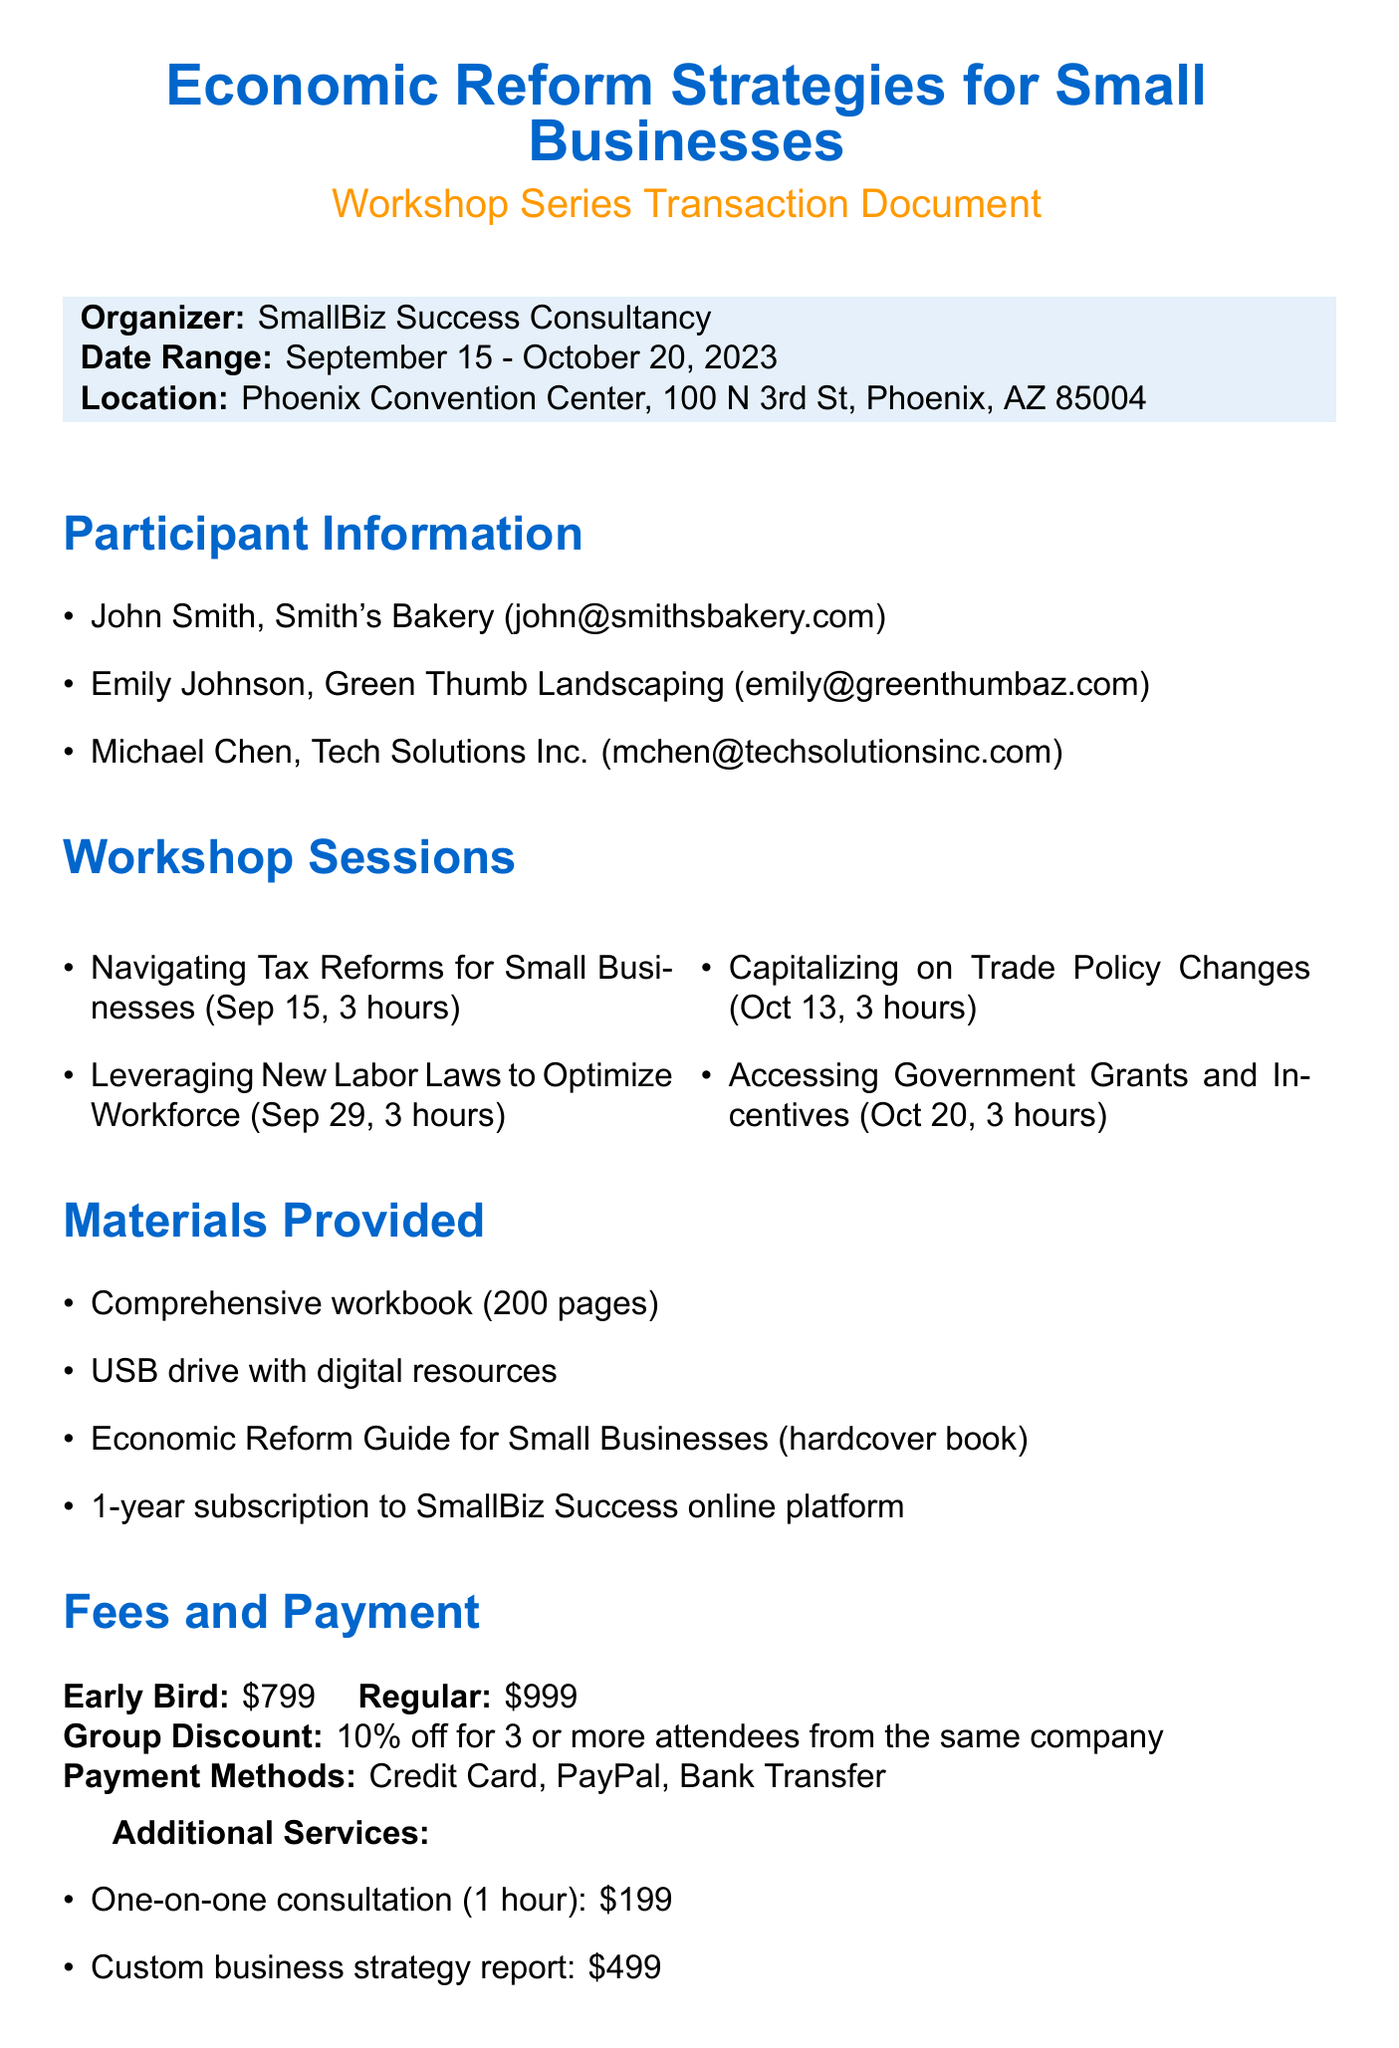What is the workshop series title? The workshop series title is explicitly stated at the top of the document.
Answer: Economic Reform Strategies for Small Businesses Who is the organizer of the workshops? The document identifies the organization responsible for the workshops.
Answer: SmallBiz Success Consultancy What is the duration of each workshop session? The duration is mentioned for each of the workshop sessions listed in the document.
Answer: 3 hours What is the early bird fee for the workshops? The early bird fee is clearly listed in the fees section of the document.
Answer: $799 How many workshop sessions are offered in total? The total number of workshops can be counted from the list in the document.
Answer: 4 What is provided as the materials for participants? The document enumerates the materials given to participants during the workshops.
Answer: Comprehensive workbook (200 pages), USB drive with digital resources, Economic Reform Guide for Small Businesses (hardcover book), 1-year subscription to SmallBiz Success online platform What is the group discount percentage given for three or more attendees? The discount percentage is indicated in the fees section for group registrations.
Answer: 10% off What is the contact person's name for the workshop? The contact person's name is located in the contact information section of the document.
Answer: Sarah Thompson What is the cancellation policy for the workshops? The cancellation policy is explicitly stated and summarizes the refund conditions based on timing.
Answer: Full refund available up to 14 days before the event. 50% refund available 7-13 days before the event. No refunds within 7 days of the event 